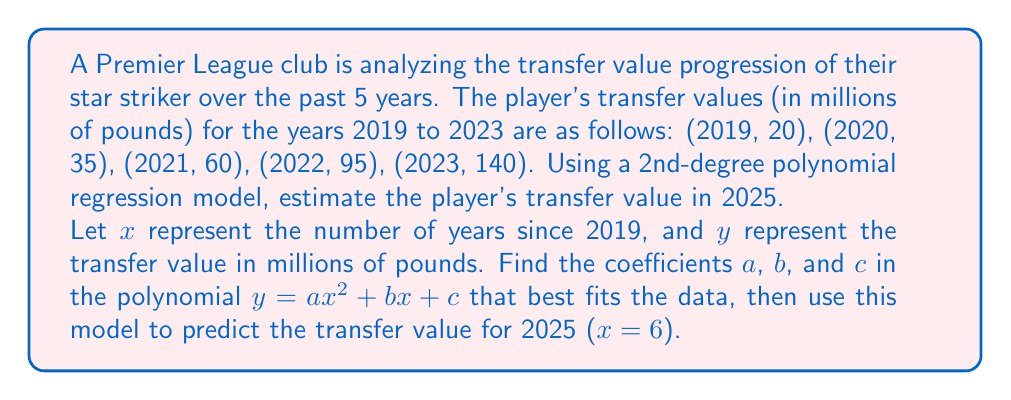Help me with this question. To solve this problem, we'll use polynomial regression to find the best-fit quadratic function. We'll follow these steps:

1) Set up the system of normal equations:
   $$\begin{cases}
   \sum y = an\sum x^2 + b\sum x + nc \\
   \sum xy = a\sum x^3 + b\sum x^2 + c\sum x \\
   \sum x^2y = a\sum x^4 + b\sum x^3 + c\sum x^2
   \end{cases}$$

2) Calculate the required sums:
   $n = 5$
   $\sum x = 0 + 1 + 2 + 3 + 4 = 10$
   $\sum x^2 = 0^2 + 1^2 + 2^2 + 3^2 + 4^2 = 30$
   $\sum x^3 = 0^3 + 1^3 + 2^3 + 3^3 + 4^3 = 100$
   $\sum x^4 = 0^4 + 1^4 + 2^4 + 3^4 + 4^4 = 354$
   $\sum y = 20 + 35 + 60 + 95 + 140 = 350$
   $\sum xy = 0(20) + 1(35) + 2(60) + 3(95) + 4(140) = 935$
   $\sum x^2y = 0^2(20) + 1^2(35) + 2^2(60) + 3^2(95) + 4^2(140) = 2710$

3) Substitute these values into the system of equations:
   $$\begin{cases}
   350 = 30a + 10b + 5c \\
   935 = 100a + 30b + 10c \\
   2710 = 354a + 100b + 30c
   \end{cases}$$

4) Solve this system of equations (using a method like Gaussian elimination or matrix operations) to find:
   $a \approx 5$, $b \approx 10$, $c \approx 20$

5) The resulting polynomial is:
   $y = 5x^2 + 10x + 20$

6) To estimate the transfer value in 2025, we substitute $x = 6$ (6 years after 2019):
   $y = 5(6^2) + 10(6) + 20 = 5(36) + 60 + 20 = 180 + 60 + 20 = 260$

Therefore, the estimated transfer value in 2025 is 260 million pounds.
Answer: 260 million pounds 